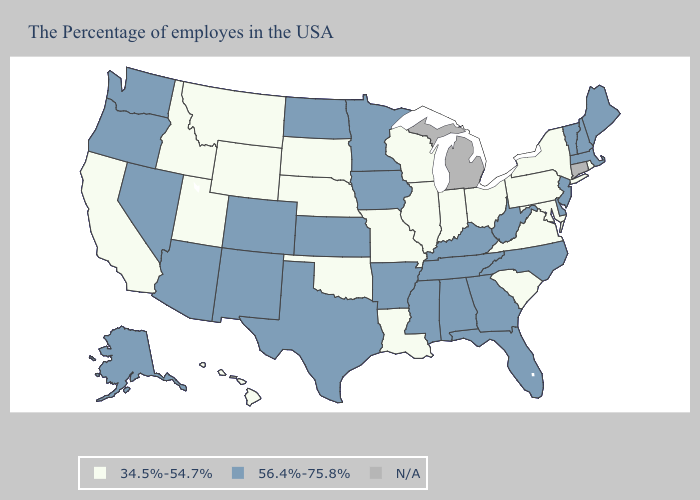Name the states that have a value in the range 34.5%-54.7%?
Answer briefly. Rhode Island, New York, Maryland, Pennsylvania, Virginia, South Carolina, Ohio, Indiana, Wisconsin, Illinois, Louisiana, Missouri, Nebraska, Oklahoma, South Dakota, Wyoming, Utah, Montana, Idaho, California, Hawaii. Does Wyoming have the lowest value in the USA?
Quick response, please. Yes. Does the map have missing data?
Keep it brief. Yes. Name the states that have a value in the range 34.5%-54.7%?
Give a very brief answer. Rhode Island, New York, Maryland, Pennsylvania, Virginia, South Carolina, Ohio, Indiana, Wisconsin, Illinois, Louisiana, Missouri, Nebraska, Oklahoma, South Dakota, Wyoming, Utah, Montana, Idaho, California, Hawaii. Name the states that have a value in the range 56.4%-75.8%?
Write a very short answer. Maine, Massachusetts, New Hampshire, Vermont, New Jersey, Delaware, North Carolina, West Virginia, Florida, Georgia, Kentucky, Alabama, Tennessee, Mississippi, Arkansas, Minnesota, Iowa, Kansas, Texas, North Dakota, Colorado, New Mexico, Arizona, Nevada, Washington, Oregon, Alaska. Name the states that have a value in the range N/A?
Quick response, please. Connecticut, Michigan. What is the highest value in states that border California?
Concise answer only. 56.4%-75.8%. Does Arizona have the highest value in the West?
Keep it brief. Yes. Which states have the highest value in the USA?
Short answer required. Maine, Massachusetts, New Hampshire, Vermont, New Jersey, Delaware, North Carolina, West Virginia, Florida, Georgia, Kentucky, Alabama, Tennessee, Mississippi, Arkansas, Minnesota, Iowa, Kansas, Texas, North Dakota, Colorado, New Mexico, Arizona, Nevada, Washington, Oregon, Alaska. What is the value of Indiana?
Concise answer only. 34.5%-54.7%. Among the states that border Arkansas , which have the highest value?
Short answer required. Tennessee, Mississippi, Texas. What is the lowest value in states that border Arkansas?
Concise answer only. 34.5%-54.7%. What is the lowest value in states that border Kentucky?
Keep it brief. 34.5%-54.7%. Name the states that have a value in the range 56.4%-75.8%?
Quick response, please. Maine, Massachusetts, New Hampshire, Vermont, New Jersey, Delaware, North Carolina, West Virginia, Florida, Georgia, Kentucky, Alabama, Tennessee, Mississippi, Arkansas, Minnesota, Iowa, Kansas, Texas, North Dakota, Colorado, New Mexico, Arizona, Nevada, Washington, Oregon, Alaska. What is the value of Wyoming?
Short answer required. 34.5%-54.7%. 